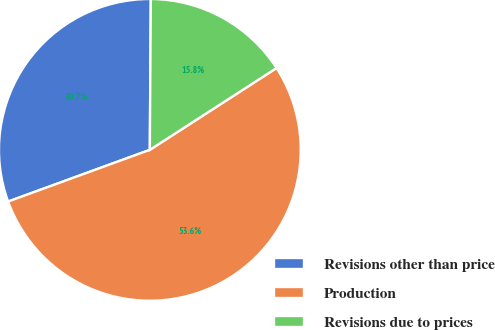<chart> <loc_0><loc_0><loc_500><loc_500><pie_chart><fcel>Revisions other than price<fcel>Production<fcel>Revisions due to prices<nl><fcel>30.67%<fcel>53.56%<fcel>15.77%<nl></chart> 